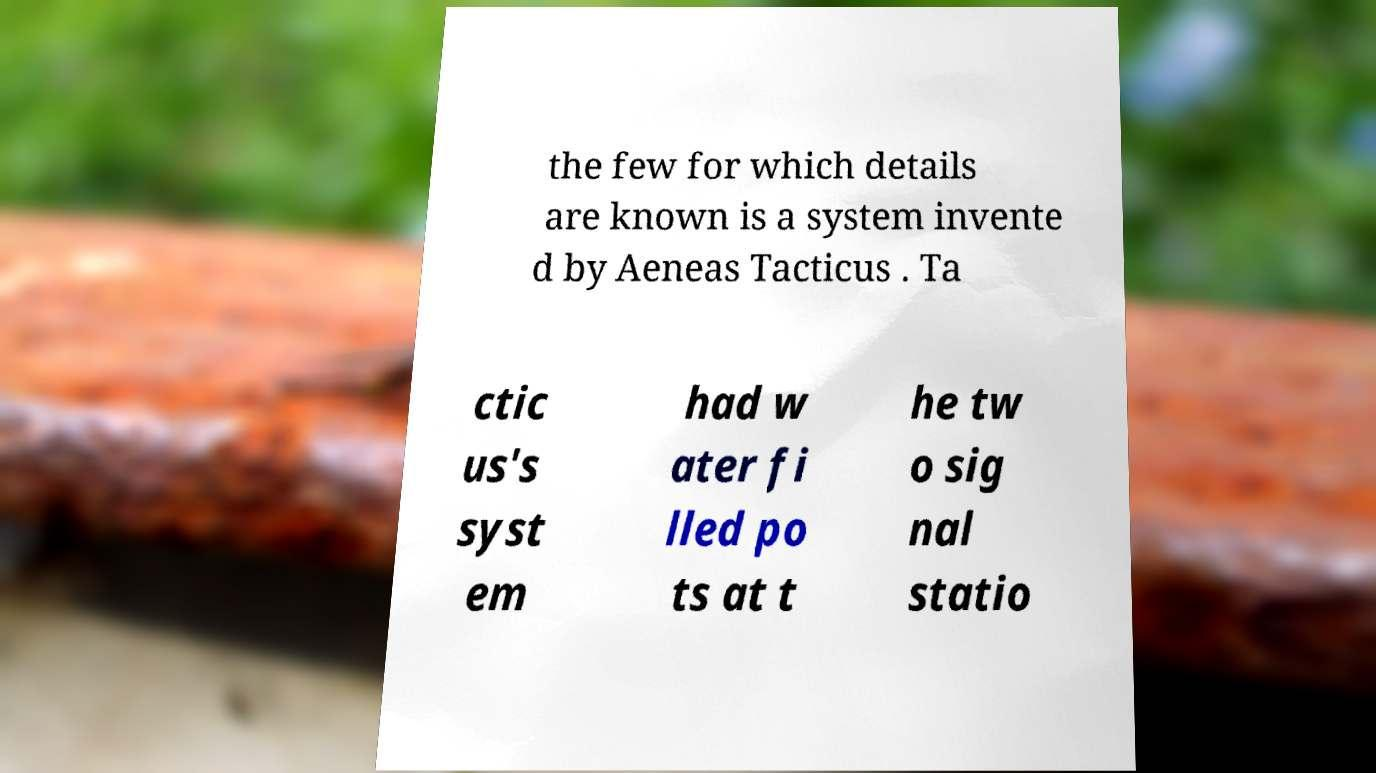Please identify and transcribe the text found in this image. the few for which details are known is a system invente d by Aeneas Tacticus . Ta ctic us's syst em had w ater fi lled po ts at t he tw o sig nal statio 